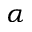Convert formula to latex. <formula><loc_0><loc_0><loc_500><loc_500>\alpha</formula> 